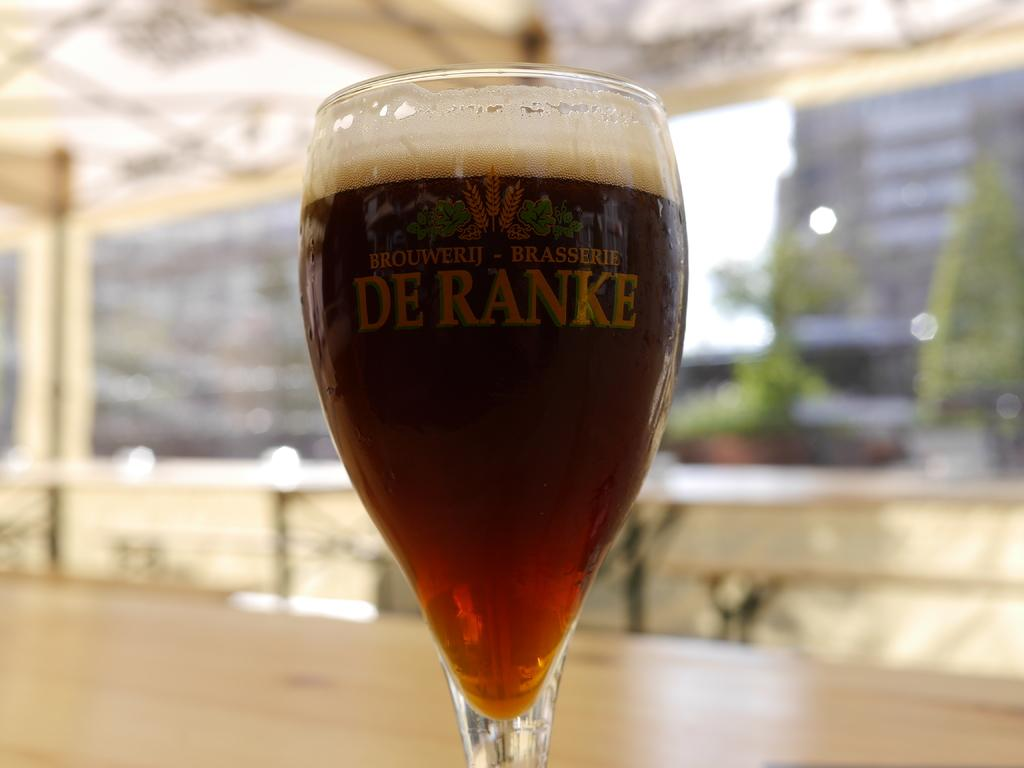<image>
Offer a succinct explanation of the picture presented. A beer glass that says Brouwerij Brasserie De Ranke. 